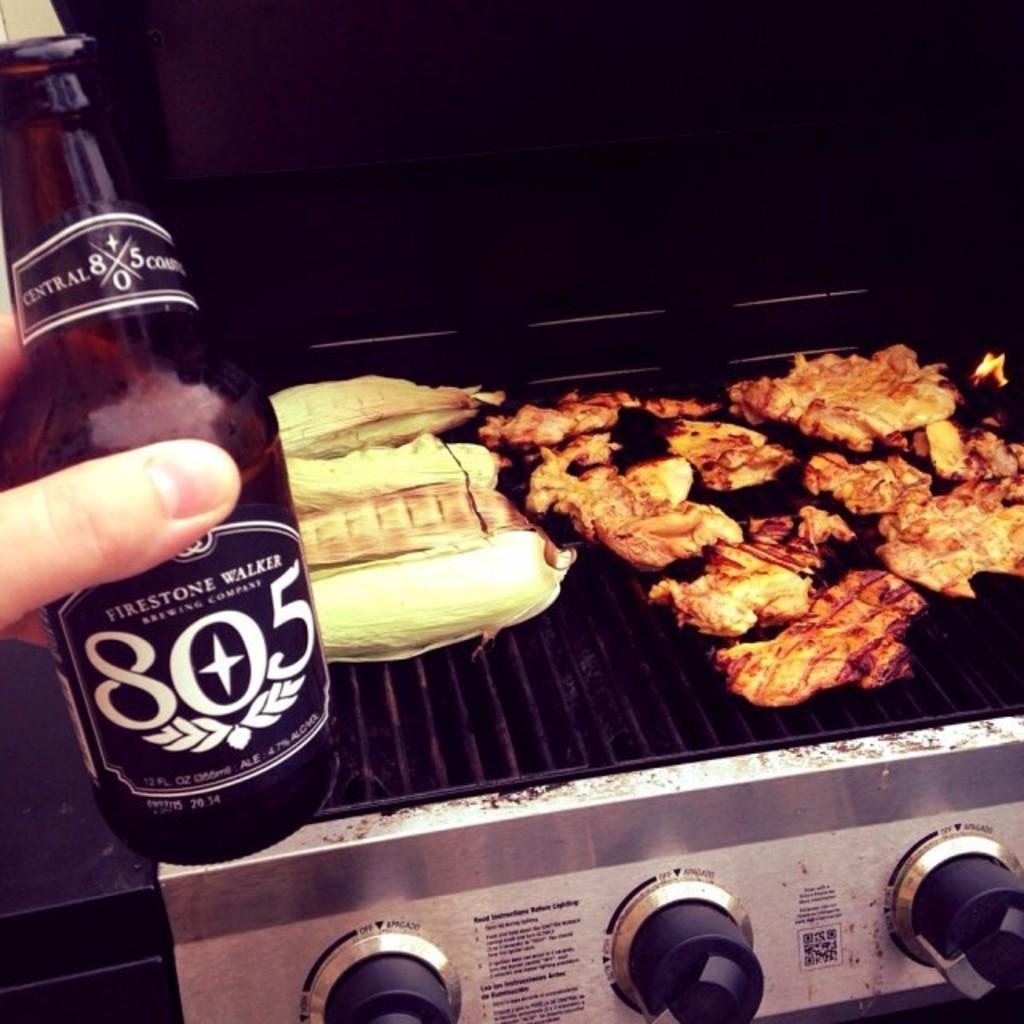<image>
Present a compact description of the photo's key features. Someone holds a bottle of Firestone Walker 805 near the grill they're cooking food on. 